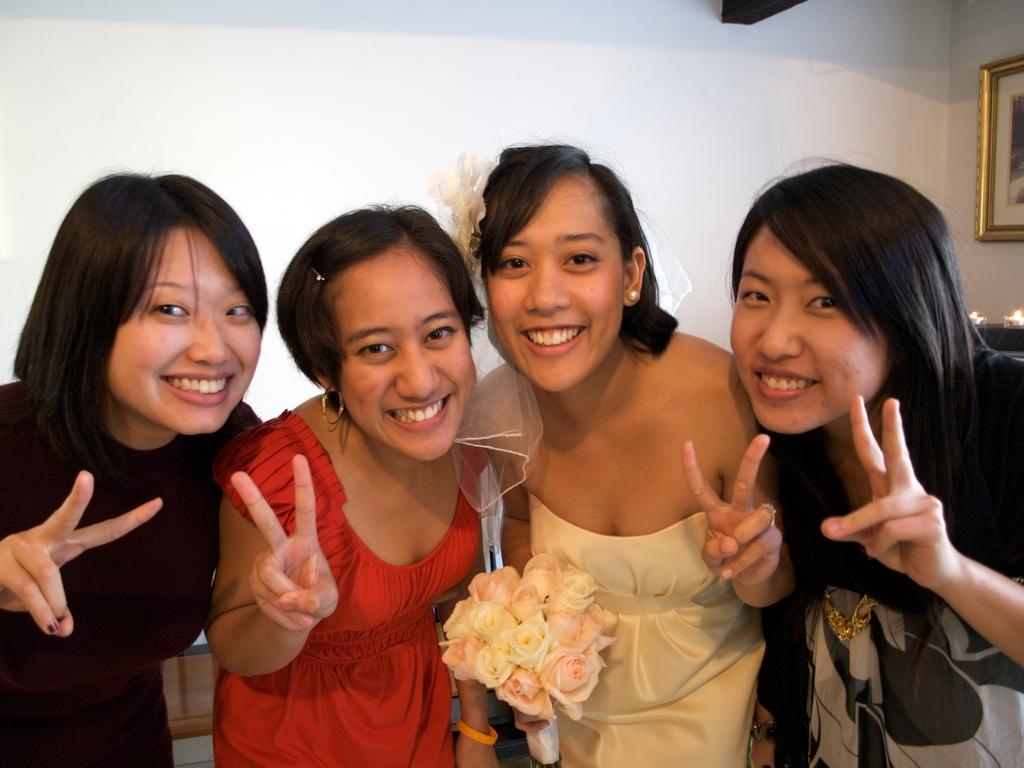In one or two sentences, can you explain what this image depicts? In this image in the front there are women standing and smiling and in the center there is a woman standing, wearing a white colour dress and holding a bouquet of flowers in her hand. In the background on the right side of the wall there is a frame. 